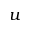<formula> <loc_0><loc_0><loc_500><loc_500>u</formula> 